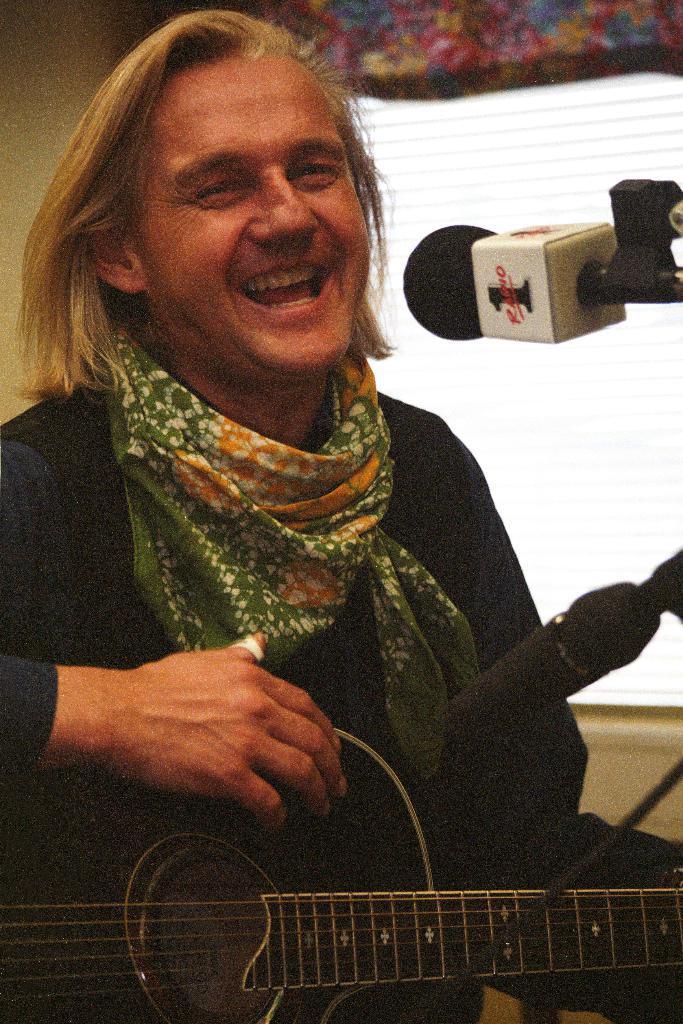Please provide a concise description of this image. There is a man in a room with a long hair and a scarf around his neck. He is wearing a black shirt. The man is holding a guitar in his hand. In Front of this man there are two microphones. One is facing this guitar and other one is facing his mouth. This man is smiling. There is a window in the background and behind this man there is a wall. 